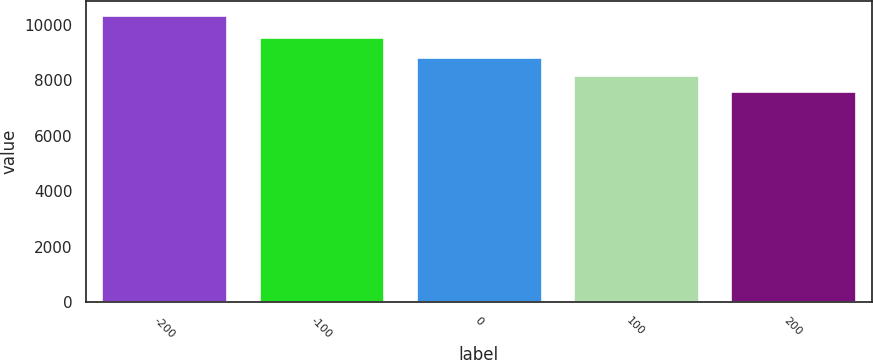Convert chart. <chart><loc_0><loc_0><loc_500><loc_500><bar_chart><fcel>-200<fcel>-100<fcel>0<fcel>100<fcel>200<nl><fcel>10357<fcel>9568<fcel>8837<fcel>8205<fcel>7615<nl></chart> 